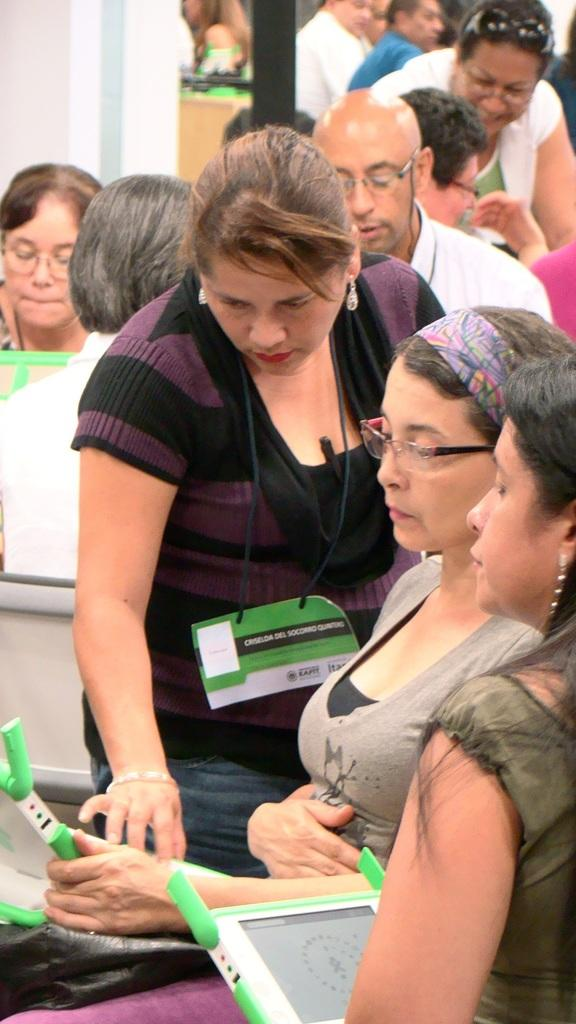Who or what can be seen in the image? There are people in the image. What are some of the people holding? Some of the people are holding tablets. What can be seen in the background of the image? There is a wall in the background of the image. How many fish are swimming in the water near the people in the image? There are no fish or water visible in the image; it features people holding tablets with a wall in the background. 